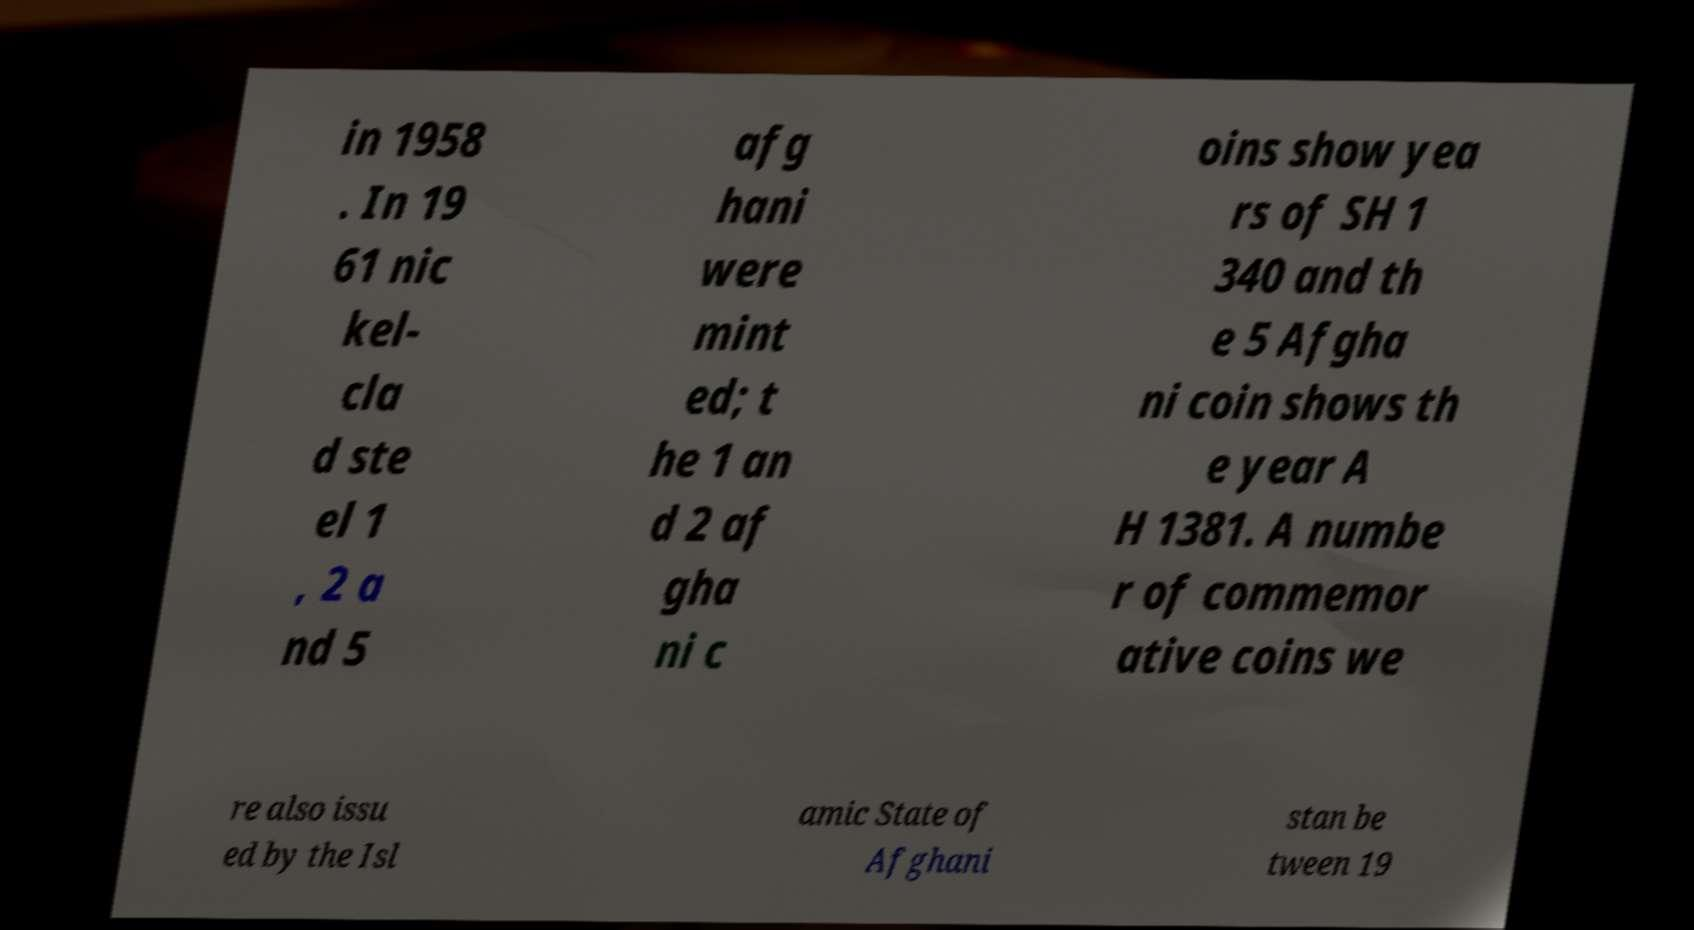Please identify and transcribe the text found in this image. in 1958 . In 19 61 nic kel- cla d ste el 1 , 2 a nd 5 afg hani were mint ed; t he 1 an d 2 af gha ni c oins show yea rs of SH 1 340 and th e 5 Afgha ni coin shows th e year A H 1381. A numbe r of commemor ative coins we re also issu ed by the Isl amic State of Afghani stan be tween 19 